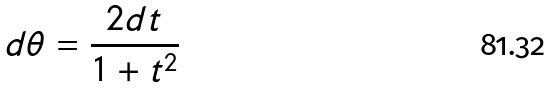Convert formula to latex. <formula><loc_0><loc_0><loc_500><loc_500>d \theta = \frac { 2 d t } { 1 + t ^ { 2 } }</formula> 